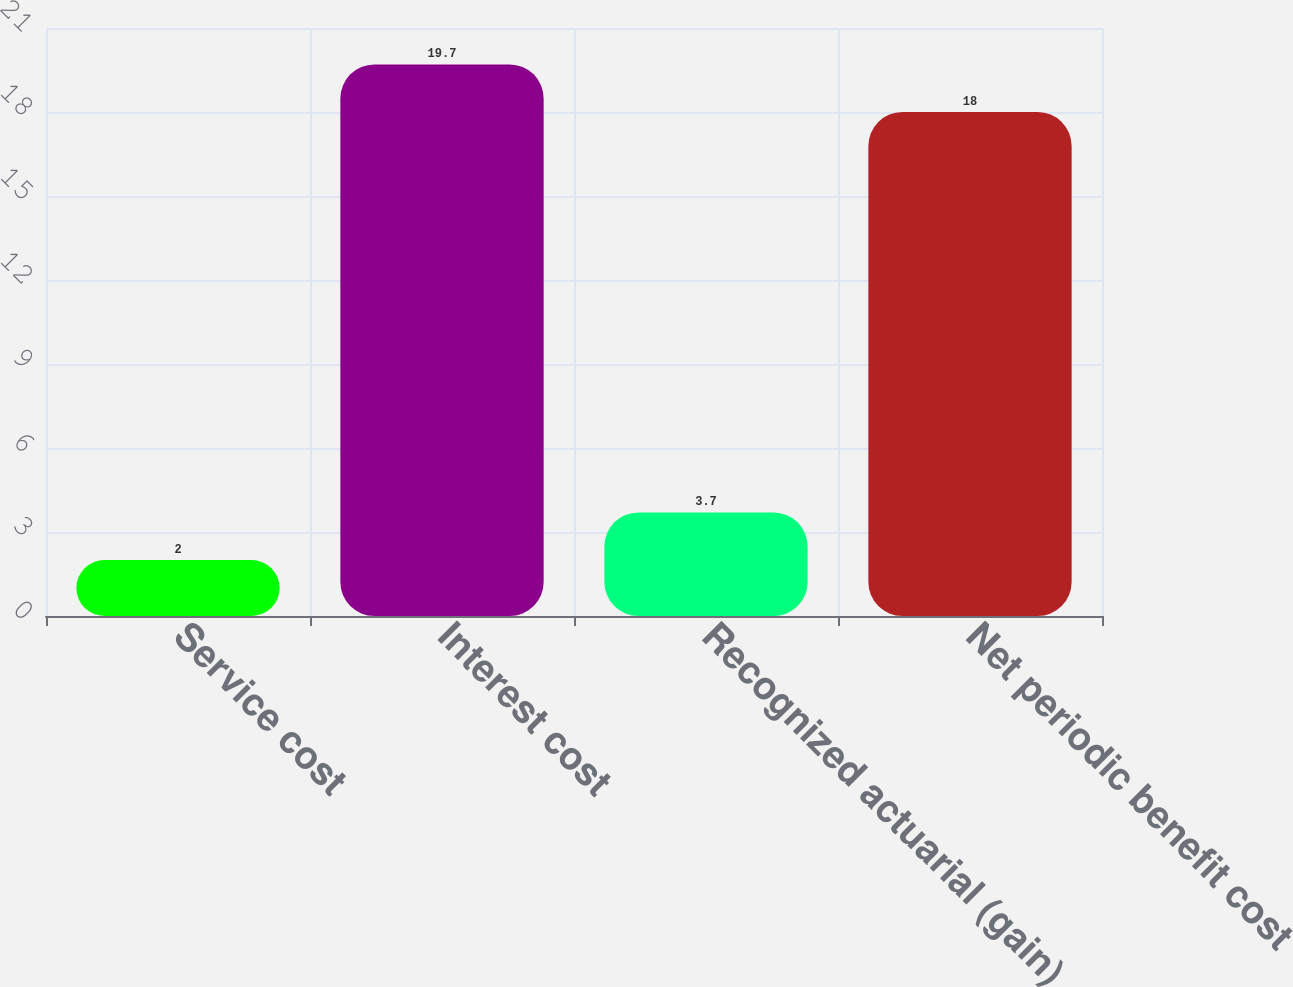<chart> <loc_0><loc_0><loc_500><loc_500><bar_chart><fcel>Service cost<fcel>Interest cost<fcel>Recognized actuarial (gain)<fcel>Net periodic benefit cost<nl><fcel>2<fcel>19.7<fcel>3.7<fcel>18<nl></chart> 